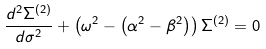<formula> <loc_0><loc_0><loc_500><loc_500>\frac { d ^ { 2 } \Sigma ^ { ( 2 ) } } { d \sigma ^ { 2 } } + \left ( \omega ^ { 2 } - \left ( { \alpha ^ { 2 } - \beta ^ { 2 } } \right ) \right ) \Sigma ^ { ( 2 ) } = 0</formula> 